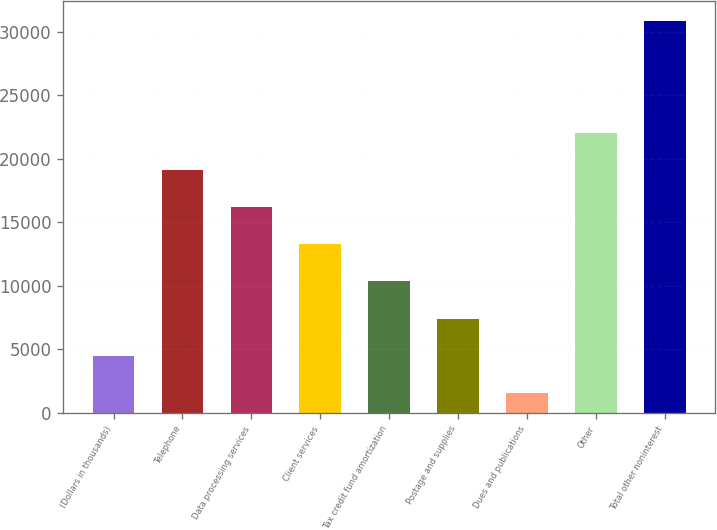Convert chart. <chart><loc_0><loc_0><loc_500><loc_500><bar_chart><fcel>(Dollars in thousands)<fcel>Telephone<fcel>Data processing services<fcel>Client services<fcel>Tax credit fund amortization<fcel>Postage and supplies<fcel>Dues and publications<fcel>Other<fcel>Total other noninterest<nl><fcel>4495.2<fcel>19121.2<fcel>16196<fcel>13270.8<fcel>10345.6<fcel>7420.4<fcel>1570<fcel>22046.4<fcel>30822<nl></chart> 